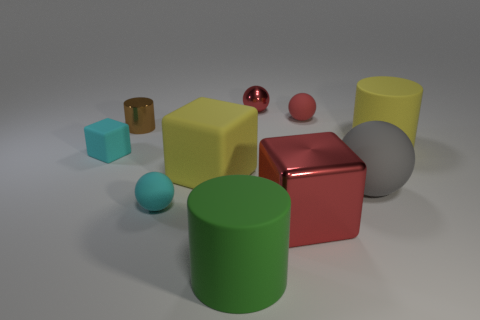Subtract all tiny blocks. How many blocks are left? 2 Subtract all balls. How many objects are left? 6 Subtract all brown cubes. Subtract all gray spheres. How many cubes are left? 3 Subtract all blue spheres. How many brown cubes are left? 0 Subtract all large red matte balls. Subtract all big green cylinders. How many objects are left? 9 Add 8 large gray spheres. How many large gray spheres are left? 9 Add 7 shiny spheres. How many shiny spheres exist? 8 Subtract all gray balls. How many balls are left? 3 Subtract 1 cyan spheres. How many objects are left? 9 Subtract 2 blocks. How many blocks are left? 1 